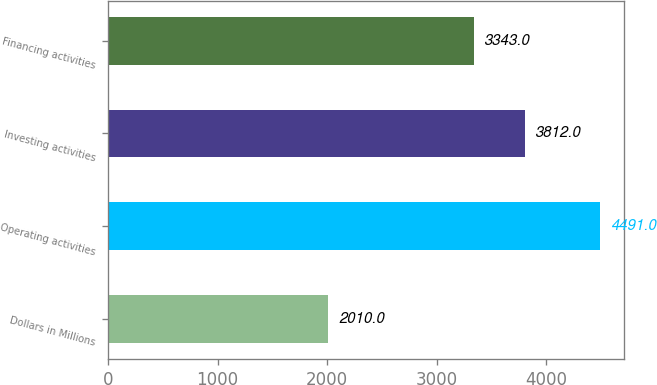<chart> <loc_0><loc_0><loc_500><loc_500><bar_chart><fcel>Dollars in Millions<fcel>Operating activities<fcel>Investing activities<fcel>Financing activities<nl><fcel>2010<fcel>4491<fcel>3812<fcel>3343<nl></chart> 